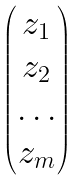Convert formula to latex. <formula><loc_0><loc_0><loc_500><loc_500>\begin{pmatrix} z _ { 1 } \\ z _ { 2 } \\ \dots \\ z _ { m } \end{pmatrix}</formula> 